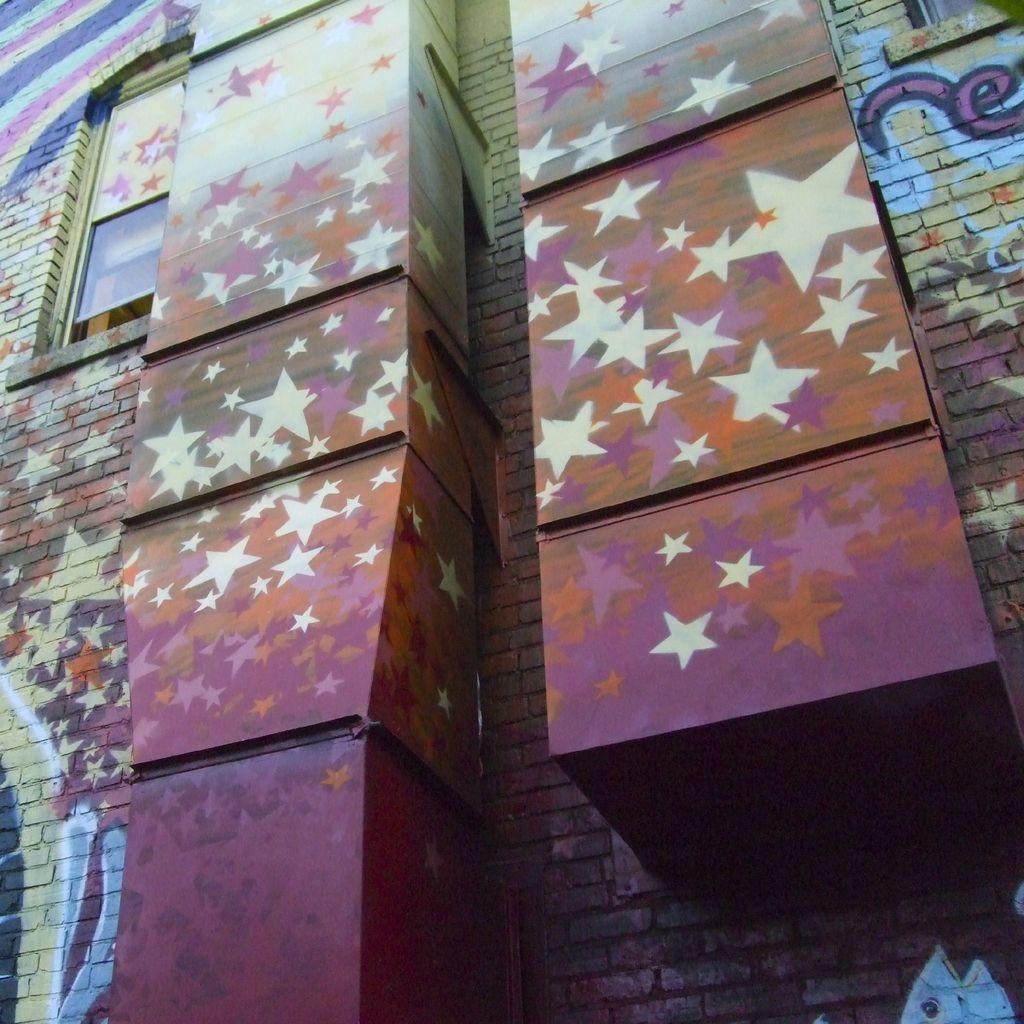What type of structure is present in the image? There is a building in the image. What is on the building in the image? There is graffiti on the building. Can you describe any other elements in the image? There are objects visible in the image. Where is the key hidden in the image? There is no key present in the image. What type of jewel can be seen on the building in the image? There is no jewel present on the building in the image. 